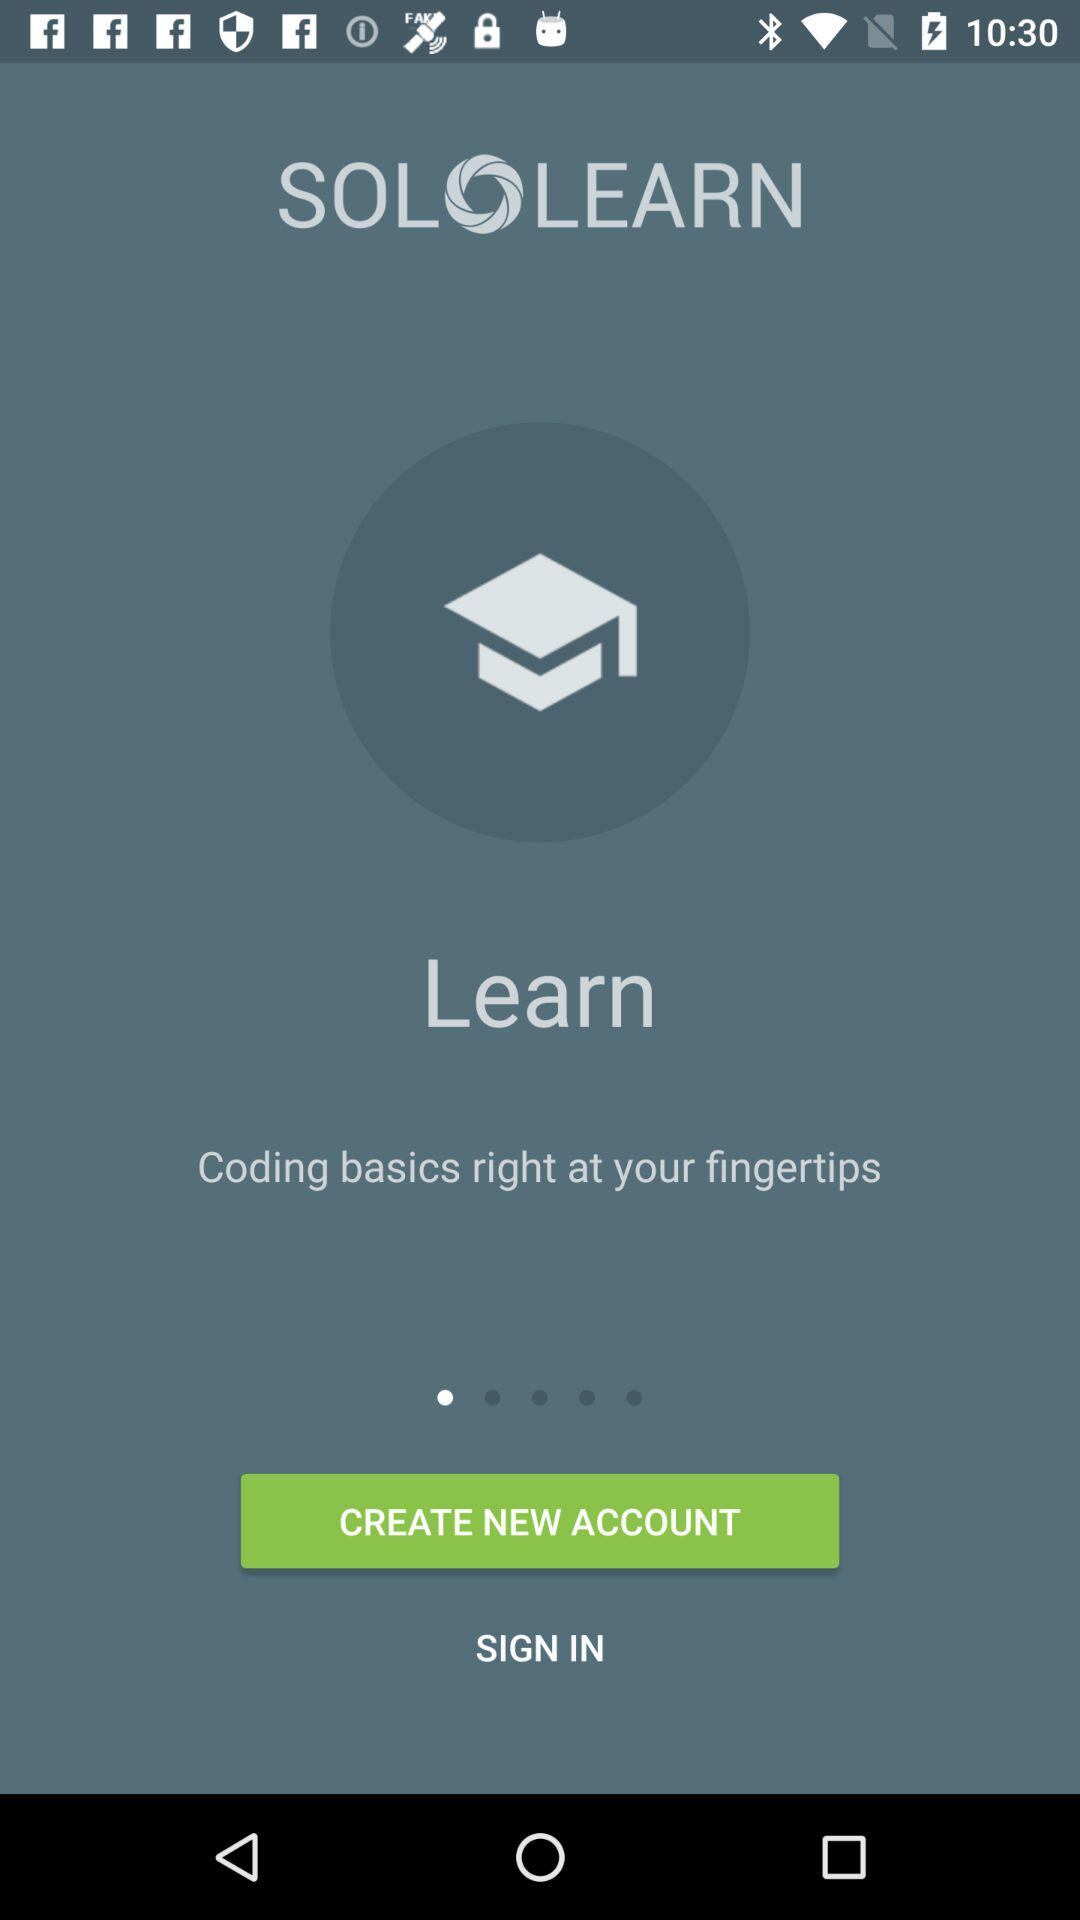What is the name of the application? The name of the application is "SOLOLEARN". 